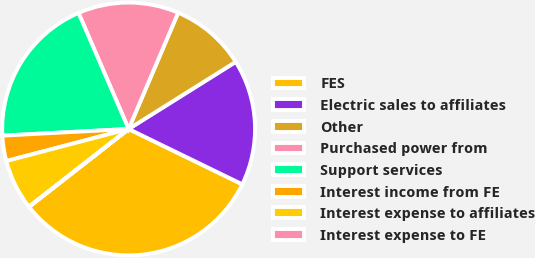<chart> <loc_0><loc_0><loc_500><loc_500><pie_chart><fcel>FES<fcel>Electric sales to affiliates<fcel>Other<fcel>Purchased power from<fcel>Support services<fcel>Interest income from FE<fcel>Interest expense to affiliates<fcel>Interest expense to FE<nl><fcel>32.23%<fcel>16.12%<fcel>9.68%<fcel>12.9%<fcel>19.35%<fcel>3.24%<fcel>6.46%<fcel>0.02%<nl></chart> 